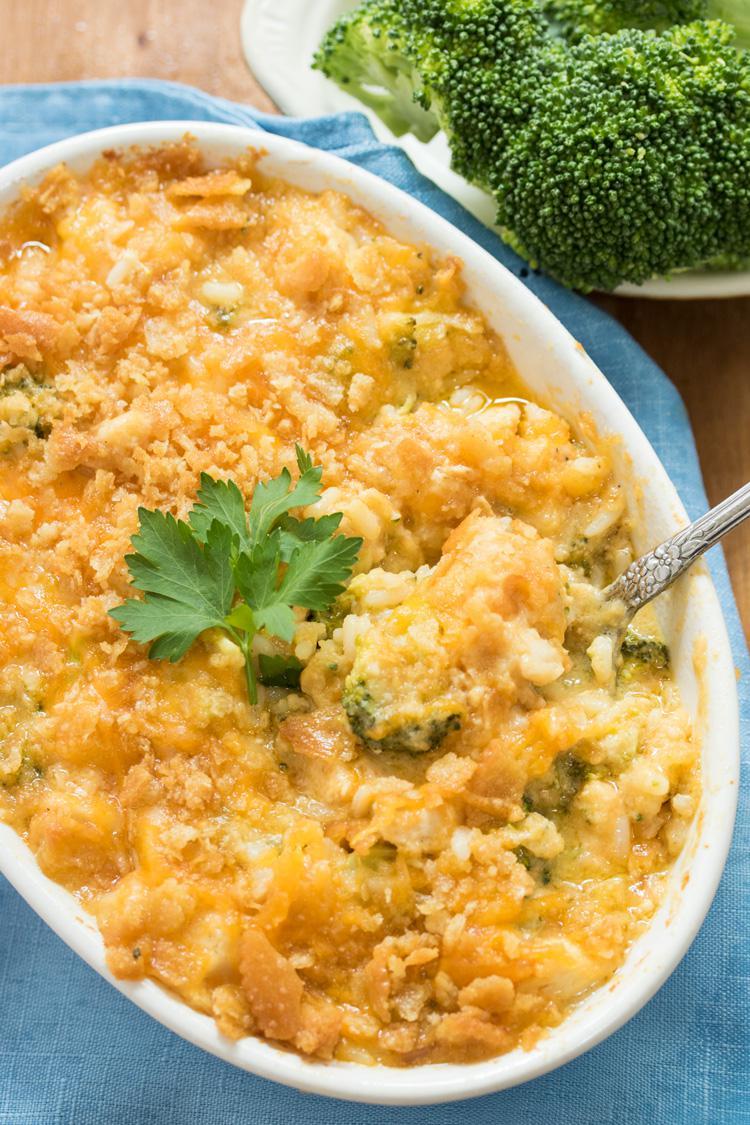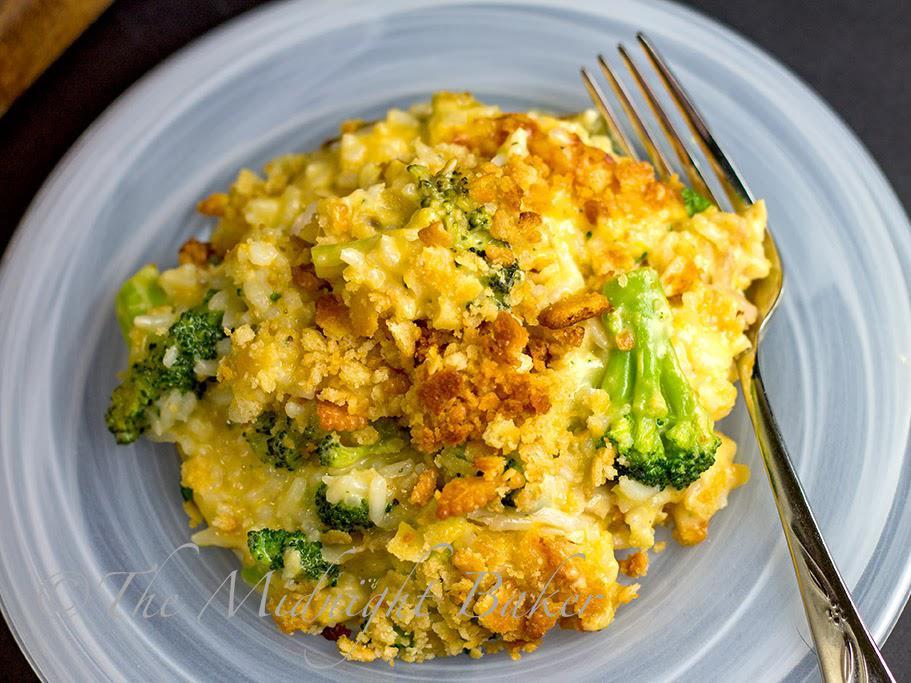The first image is the image on the left, the second image is the image on the right. For the images displayed, is the sentence "The casserole sits in a blue and white dish in one of the images." factually correct? Answer yes or no. Yes. The first image is the image on the left, the second image is the image on the right. Analyze the images presented: Is the assertion "Right image shows a casserole served in a white squarish dish, with a silver serving utensil." valid? Answer yes or no. No. 